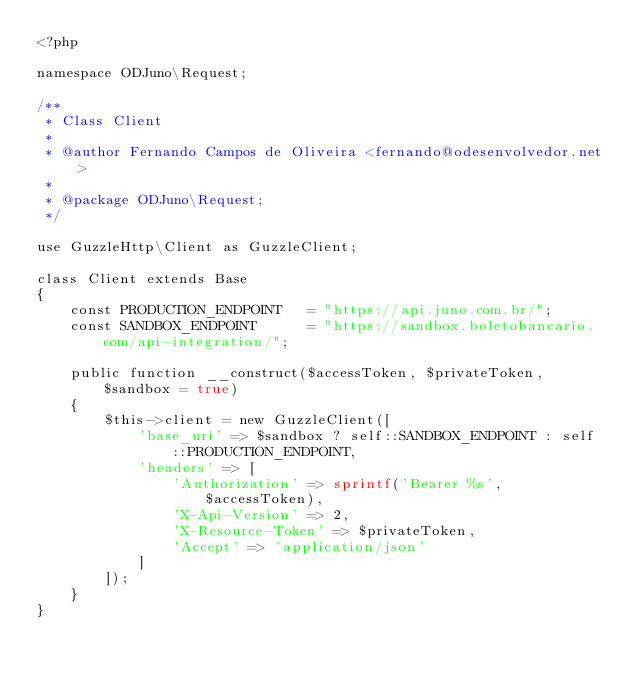<code> <loc_0><loc_0><loc_500><loc_500><_PHP_><?php

namespace ODJuno\Request;

/**
 * Class Client
 *
 * @author Fernando Campos de Oliveira <fernando@odesenvolvedor.net>
 * 
 * @package ODJuno\Request;
 */

use GuzzleHttp\Client as GuzzleClient;

class Client extends Base
{
    const PRODUCTION_ENDPOINT   = "https://api.juno.com.br/";
    const SANDBOX_ENDPOINT      = "https://sandbox.boletobancario.com/api-integration/";

    public function __construct($accessToken, $privateToken, $sandbox = true)
    {
        $this->client = new GuzzleClient([
            'base_uri' => $sandbox ? self::SANDBOX_ENDPOINT : self::PRODUCTION_ENDPOINT,
            'headers' => [
                'Authorization' => sprintf('Bearer %s', $accessToken),
                'X-Api-Version' => 2,
                'X-Resource-Token' => $privateToken,
                'Accept' => 'application/json'
            ]
        ]);
    }
}</code> 